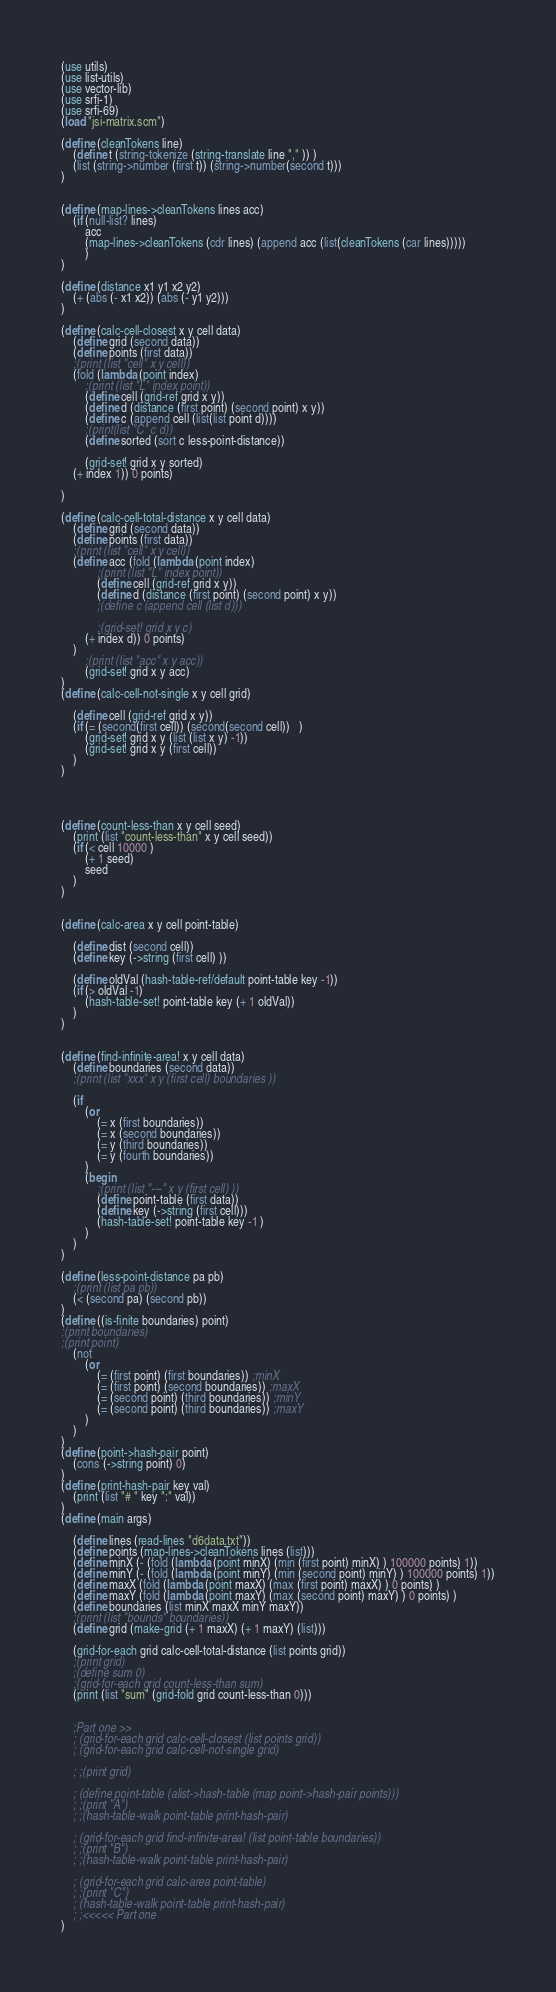<code> <loc_0><loc_0><loc_500><loc_500><_Scheme_>(use utils)
(use list-utils)
(use vector-lib)
(use srfi-1)
(use srfi-69)
(load "jsi-matrix.scm")

(define (cleanTokens line)
    (define t (string-tokenize (string-translate line "," )) )
    (list (string->number (first t)) (string->number(second t)))
)


(define (map-lines->cleanTokens lines acc)
	(if (null-list? lines)
		acc
		(map-lines->cleanTokens (cdr lines) (append acc (list(cleanTokens (car lines)))))
		)
)

(define (distance x1 y1 x2 y2)
    (+ (abs (- x1 x2)) (abs (- y1 y2)))
)

(define (calc-cell-closest x y cell data)
    (define grid (second data))
    (define points (first data))
    ;(print (list "cell" x y cell))
    (fold (lambda (point index) 
        ;(print (list "L" index point))
        (define cell (grid-ref grid x y))
        (define d (distance (first point) (second point) x y))
        (define c (append cell (list(list point d))))
        ;(print(list "C" c d))
        (define sorted (sort c less-point-distance))
        
        (grid-set! grid x y sorted)
    (+ index 1)) 0 points)

)

(define (calc-cell-total-distance x y cell data)
    (define grid (second data))
    (define points (first data))
    ;(print (list "cell" x y cell))
    (define acc (fold (lambda (point index) 
            ;(print (list "L" index point))
            (define cell (grid-ref grid x y))
            (define d (distance (first point) (second point) x y))
            ;(define c (append cell (list d)))
            
            ;(grid-set! grid x y c)
        (+ index d)) 0 points)
    )
        ;(print (list "acc" x y acc))
        (grid-set! grid x y acc)
)
(define (calc-cell-not-single x y cell grid)
    
    (define cell (grid-ref grid x y))
    (if (= (second(first cell)) (second(second cell))   )
        (grid-set! grid x y (list (list x y) -1))
        (grid-set! grid x y (first cell))
    )
)




(define (count-less-than x y cell seed)
    (print (list "count-less-than" x y cell seed))
    (if (< cell 10000 )
        (+ 1 seed)
        seed
    )
)


(define (calc-area x y cell point-table)
    
    (define dist (second cell))
    (define key (->string (first cell) ))
    
    (define oldVal (hash-table-ref/default point-table key -1))
    (if (> oldVal -1)
        (hash-table-set! point-table key (+ 1 oldVal))
    )
)


(define (find-infinite-area! x y cell data)    
    (define boundaries (second data))
    ;(print (list "xxx" x y (first cell) boundaries ))

    (if
        (or
            (= x (first boundaries))
            (= x (second boundaries))
            (= y (third boundaries))
            (= y (fourth boundaries))
        )
        (begin
            ;(print (list "---" x y (first cell) ))
            (define point-table (first data))
            (define key (->string (first cell)))
            (hash-table-set! point-table key -1 )
        )
    )
)

(define (less-point-distance pa pb) 
    ;(print (list pa pb))
    (< (second pa) (second pb))
)
(define ((is-finite boundaries) point)
;(print boundaries)
;(print point)
    (not
        (or
            (= (first point) (first boundaries)) ;minX
            (= (first point) (second boundaries)) ;maxX
            (= (second point) (third boundaries)) ;minY
            (= (second point) (third boundaries)) ;maxY
        )
    )
)
(define (point->hash-pair point)
    (cons (->string point) 0)
)
(define (print-hash-pair key val)
    (print (list "# " key ":" val))
)
(define (main args)

    (define lines (read-lines "d6data.txt"))
    (define points (map-lines->cleanTokens lines (list)))
    (define minX (- (fold (lambda (point minX) (min (first point) minX) ) 100000 points) 1))
    (define minY (- (fold (lambda (point minY) (min (second point) minY) ) 100000 points) 1))
    (define maxX (fold (lambda (point maxX) (max (first point) maxX) ) 0 points) )
    (define maxY (fold (lambda (point maxY) (max (second point) maxY) ) 0 points) )
    (define boundaries (list minX maxX minY maxY))
    ;(print (list "bounds" boundaries))
    (define grid (make-grid (+ 1 maxX) (+ 1 maxY) (list)))
    
    (grid-for-each grid calc-cell-total-distance (list points grid))
    ;(print grid)
    ;(define sum 0)
    ;(grid-for-each grid count-less-than sum)
    (print (list "sum" (grid-fold grid count-less-than 0)))
 
    
    ;Part one >>
    ; (grid-for-each grid calc-cell-closest (list points grid))
    ; (grid-for-each grid calc-cell-not-single grid)
    
    ; ;(print grid)

    ; (define point-table (alist->hash-table (map point->hash-pair points)))
    ; ;(print "A")
    ; ;(hash-table-walk point-table print-hash-pair)

    ; (grid-for-each grid find-infinite-area! (list point-table boundaries))
    ; ;(print "B")
    ; ;(hash-table-walk point-table print-hash-pair)

    ; (grid-for-each grid calc-area point-table)
    ; ;(print "C")
    ; (hash-table-walk point-table print-hash-pair)
    ; ;<<<<< Part one
)</code> 